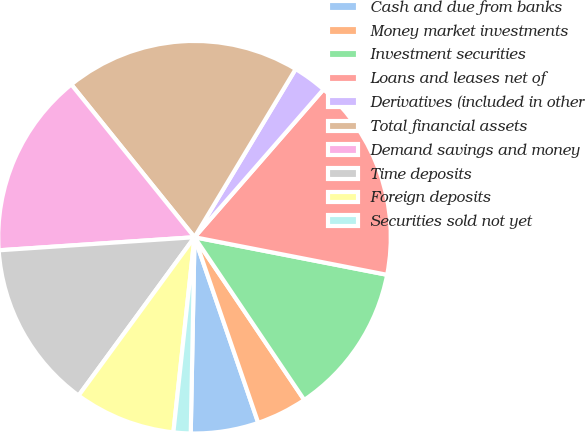<chart> <loc_0><loc_0><loc_500><loc_500><pie_chart><fcel>Cash and due from banks<fcel>Money market investments<fcel>Investment securities<fcel>Loans and leases net of<fcel>Derivatives (included in other<fcel>Total financial assets<fcel>Demand savings and money<fcel>Time deposits<fcel>Foreign deposits<fcel>Securities sold not yet<nl><fcel>5.57%<fcel>4.18%<fcel>12.49%<fcel>16.65%<fcel>2.8%<fcel>19.42%<fcel>15.26%<fcel>13.88%<fcel>8.34%<fcel>1.41%<nl></chart> 